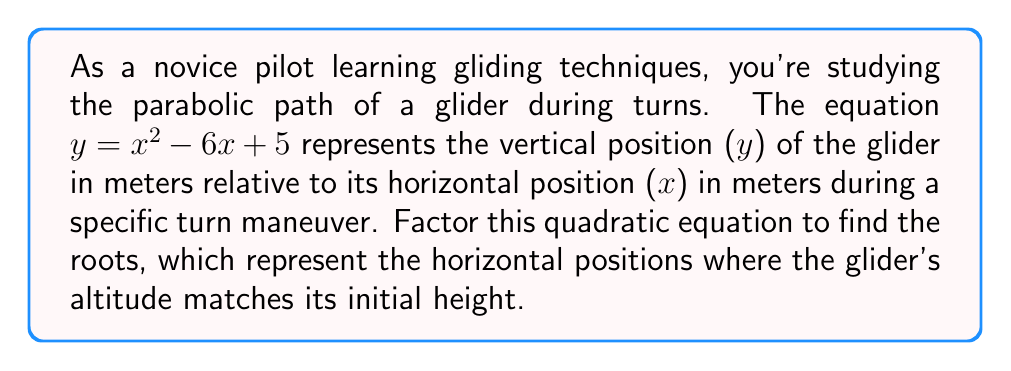Provide a solution to this math problem. To factor this quadratic equation, we'll follow these steps:

1) First, identify the coefficients:
   $a = 1$, $b = -6$, and $c = 5$

2) We're looking for two numbers that multiply to give $ac = 1 \times 5 = 5$ and add up to $b = -6$

3) These numbers are $-1$ and $-5$

4) Rewrite the middle term using these numbers:
   $y = x^2 - x - 5x + 5$

5) Group the terms:
   $y = (x^2 - x) + (-5x + 5)$

6) Factor out the common factor from each group:
   $y = x(x - 1) - 5(x - 1)$

7) Factor out the common binomial $(x - 1)$:
   $y = (x - 1)(x - 5)$

Therefore, the factored form of the equation is $y = (x - 1)(x - 5)$

The roots of this equation (where $y = 0$) are $x = 1$ and $x = 5$, which represent the horizontal positions where the glider's altitude matches its initial height.
Answer: $y = (x - 1)(x - 5)$ 